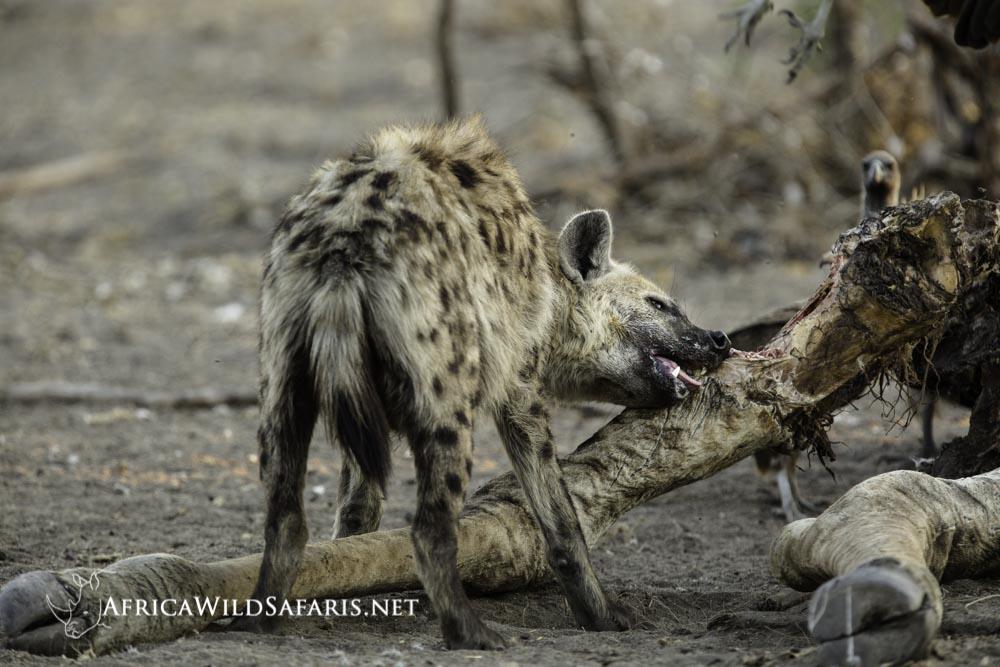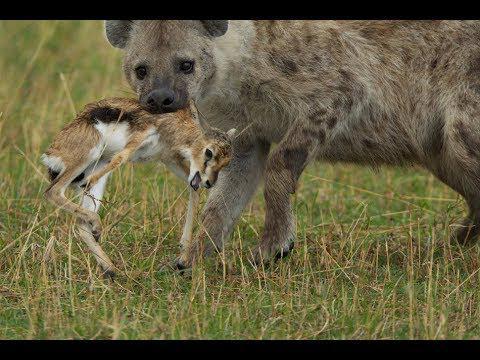The first image is the image on the left, the second image is the image on the right. Evaluate the accuracy of this statement regarding the images: "Each image includes the carcass of a giraffe with at least some of its distinctively patterned hide intact, and the right image features a hyena with its head bent to the carcass.". Is it true? Answer yes or no. No. The first image is the image on the left, the second image is the image on the right. Given the left and right images, does the statement "There are three brown and spotted hyenas  eat the carcass of a giraffe ." hold true? Answer yes or no. No. 